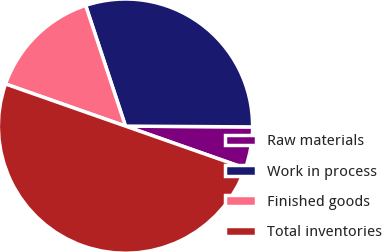<chart> <loc_0><loc_0><loc_500><loc_500><pie_chart><fcel>Raw materials<fcel>Work in process<fcel>Finished goods<fcel>Total inventories<nl><fcel>5.28%<fcel>30.17%<fcel>14.55%<fcel>50.0%<nl></chart> 